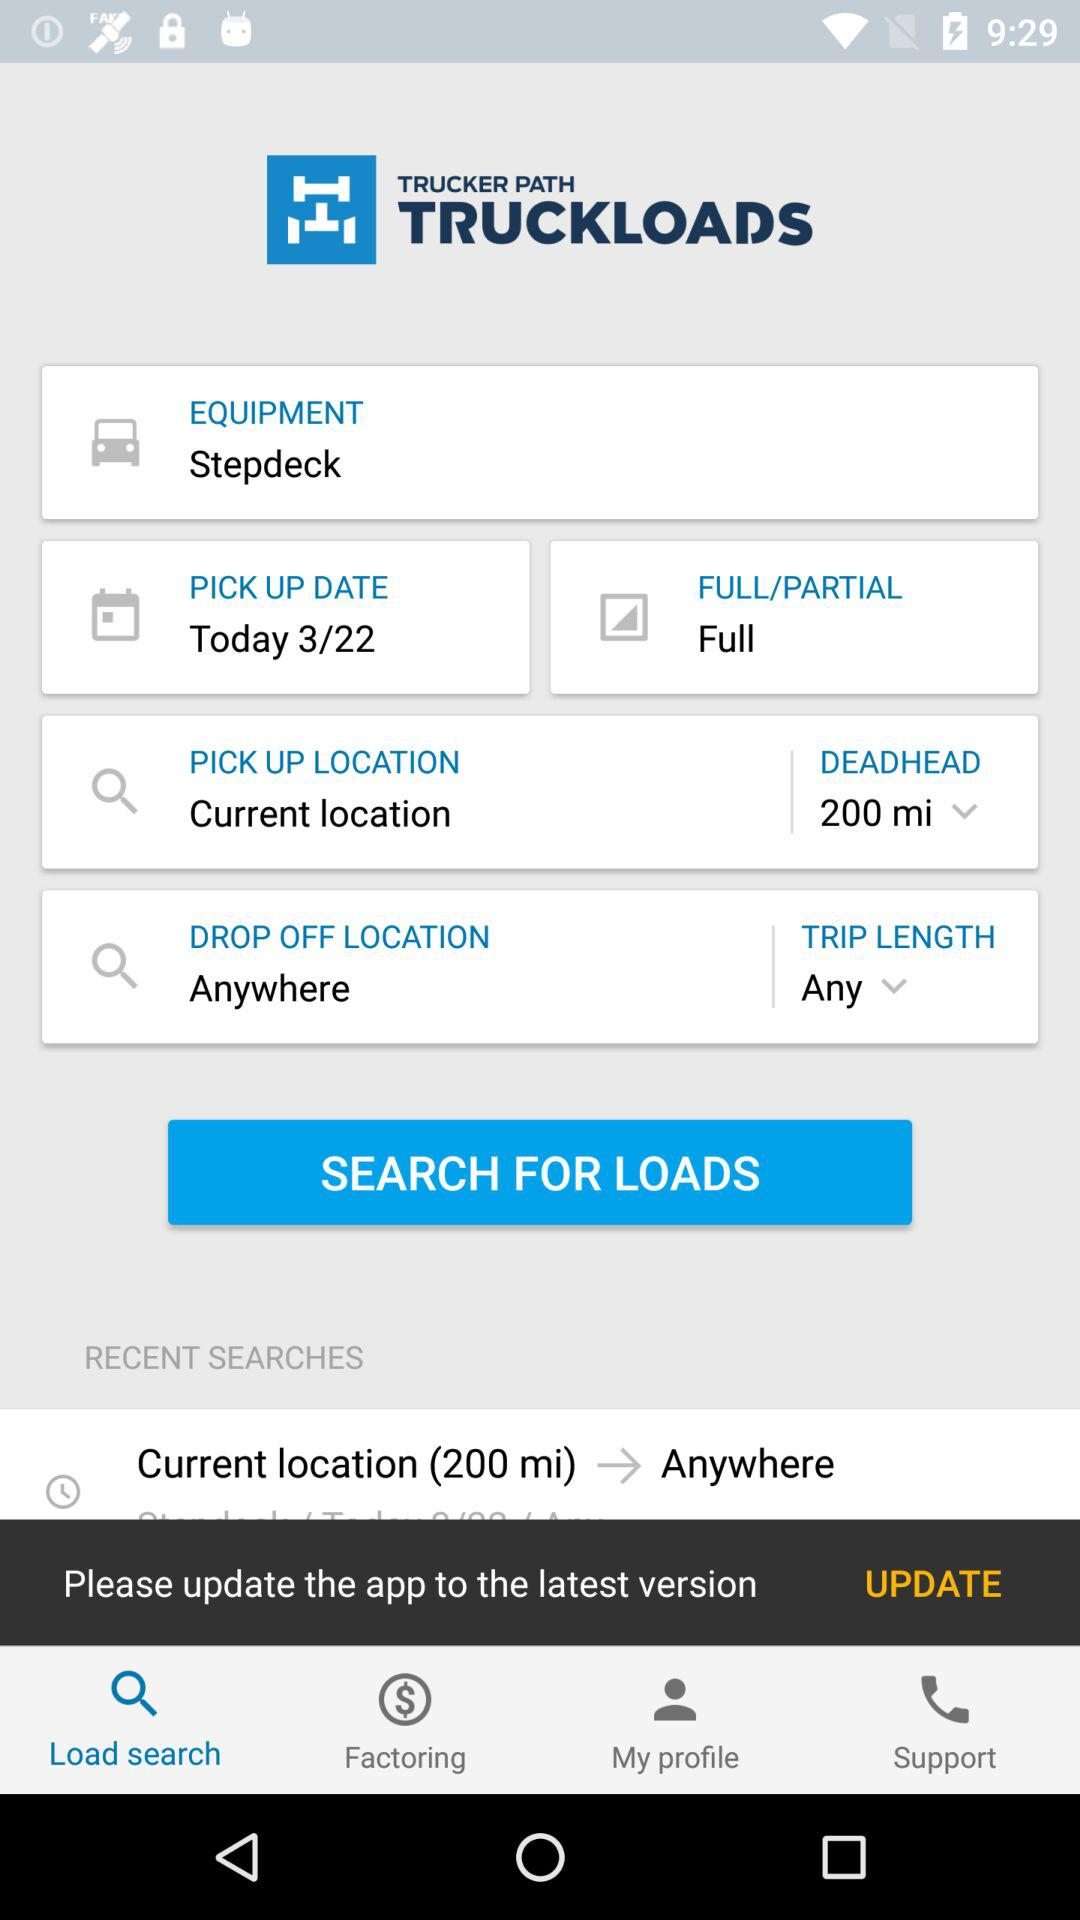What is the pickup location? The pickup location is the current location. 